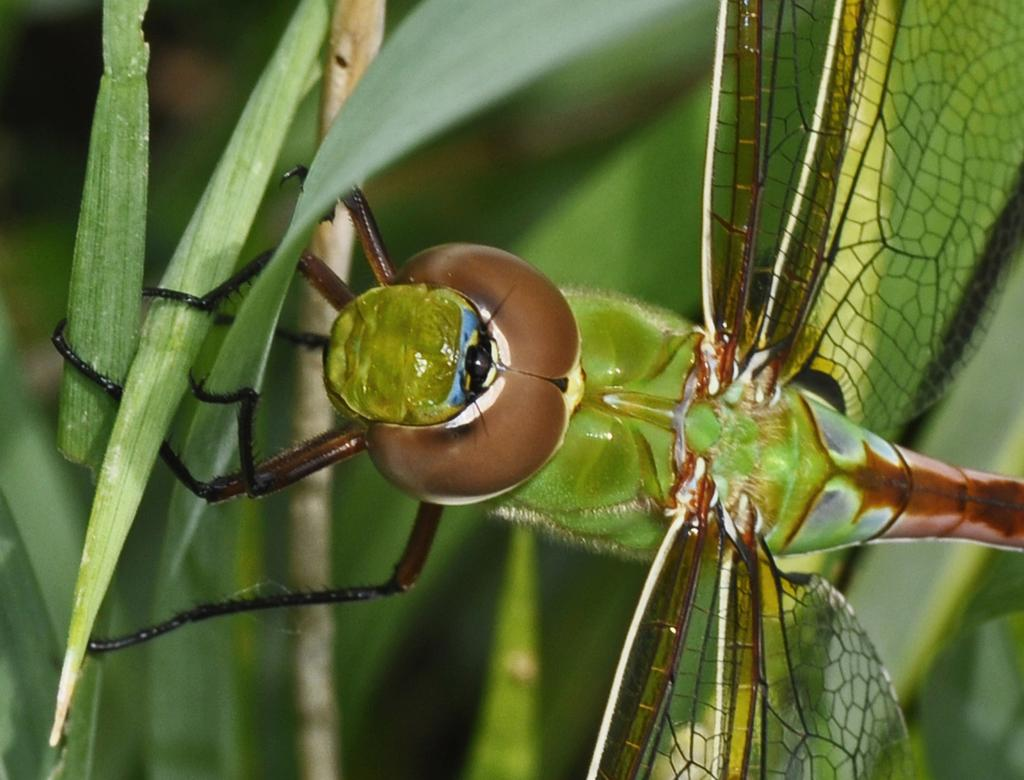What is the main subject of the image? There is a dragonfly in the image. Where is the dragonfly located? The dragonfly is on a plant. What is the color of the dragonfly? The dragonfly is green in color. Does the dragonfly have any specific features? Yes, the dragonfly has wings. Can you describe the background of the image? The background of the image is blurry. How many dimes can be seen on the dragonfly in the image? There are no dimes present on the dragonfly in the image. What type of hose is connected to the plant in the image? There is no hose connected to the plant in the image; it only features a dragonfly. 